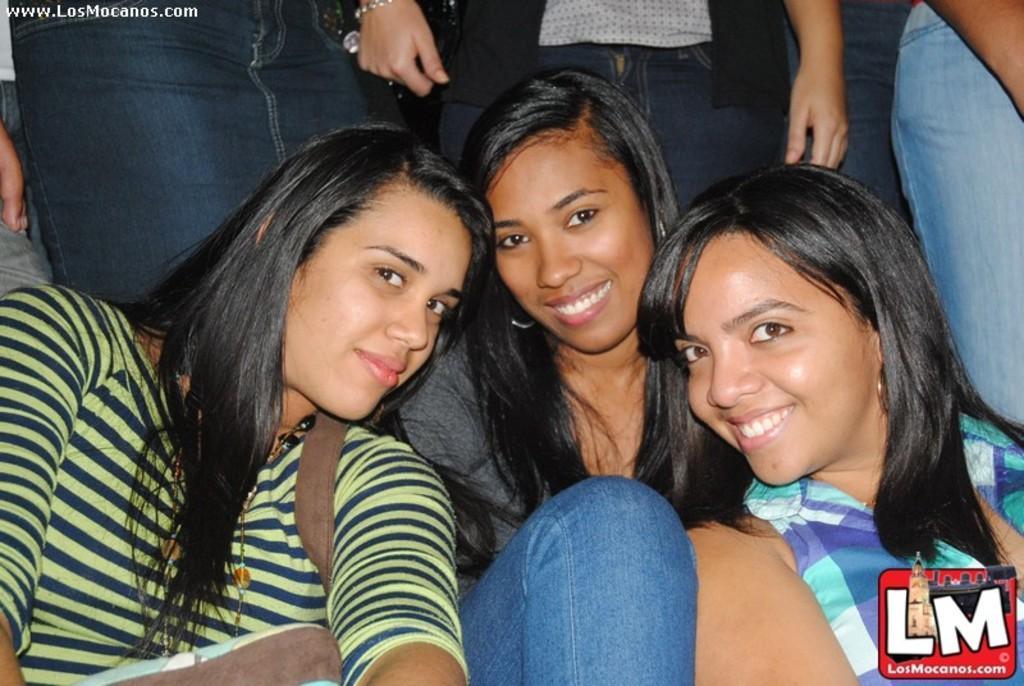How would you summarize this image in a sentence or two? In this picture there are girls those who are sitting in the center of the image and there are other people at the top side of the image. 